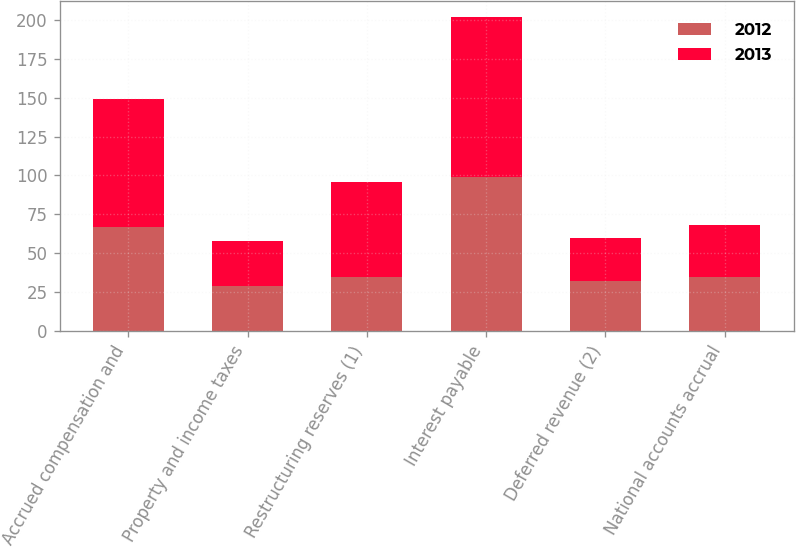Convert chart. <chart><loc_0><loc_0><loc_500><loc_500><stacked_bar_chart><ecel><fcel>Accrued compensation and<fcel>Property and income taxes<fcel>Restructuring reserves (1)<fcel>Interest payable<fcel>Deferred revenue (2)<fcel>National accounts accrual<nl><fcel>2012<fcel>67<fcel>29<fcel>35<fcel>99<fcel>32<fcel>35<nl><fcel>2013<fcel>82<fcel>29<fcel>61<fcel>103<fcel>28<fcel>33<nl></chart> 